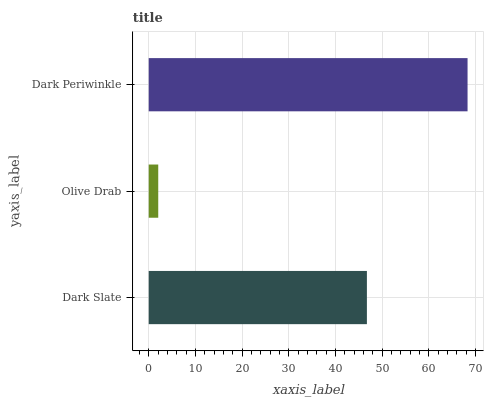Is Olive Drab the minimum?
Answer yes or no. Yes. Is Dark Periwinkle the maximum?
Answer yes or no. Yes. Is Dark Periwinkle the minimum?
Answer yes or no. No. Is Olive Drab the maximum?
Answer yes or no. No. Is Dark Periwinkle greater than Olive Drab?
Answer yes or no. Yes. Is Olive Drab less than Dark Periwinkle?
Answer yes or no. Yes. Is Olive Drab greater than Dark Periwinkle?
Answer yes or no. No. Is Dark Periwinkle less than Olive Drab?
Answer yes or no. No. Is Dark Slate the high median?
Answer yes or no. Yes. Is Dark Slate the low median?
Answer yes or no. Yes. Is Dark Periwinkle the high median?
Answer yes or no. No. Is Dark Periwinkle the low median?
Answer yes or no. No. 